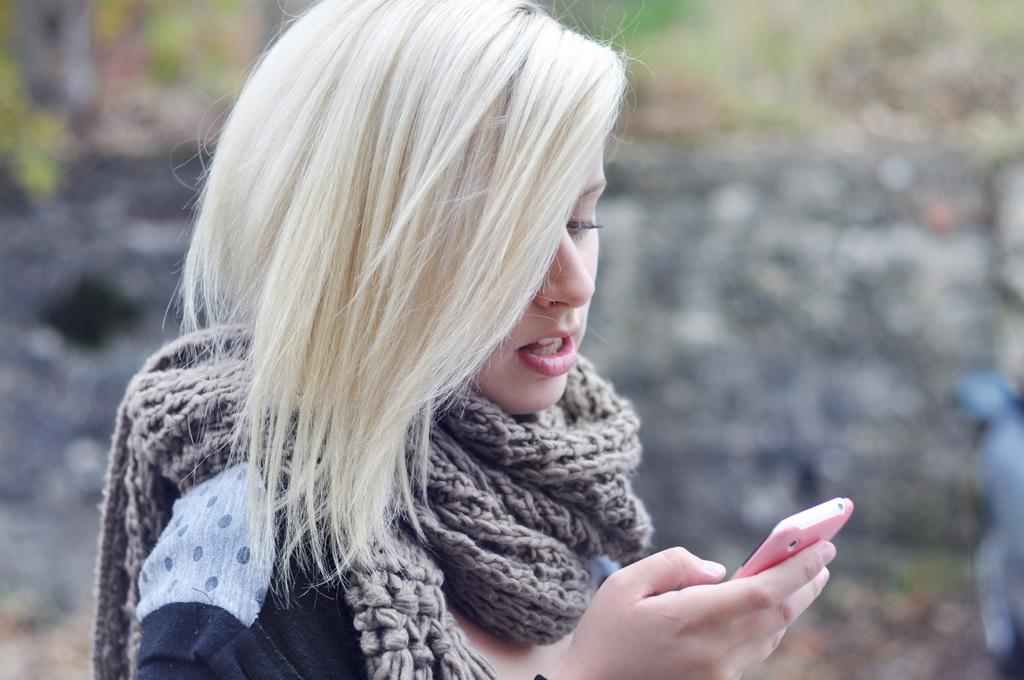What is the main subject of the image? The main subject of the image is a woman. What is the woman holding in the image? The woman is holding a phone. Can you describe the woman's hair color in the image? The woman has blonde hair. What type of chain can be seen around the woman's neck in the image? There is no chain visible around the woman's neck in the image. What verse from a religious text is the woman reciting in the image? There is no indication in the image that the woman is reciting any verse from a religious text. 